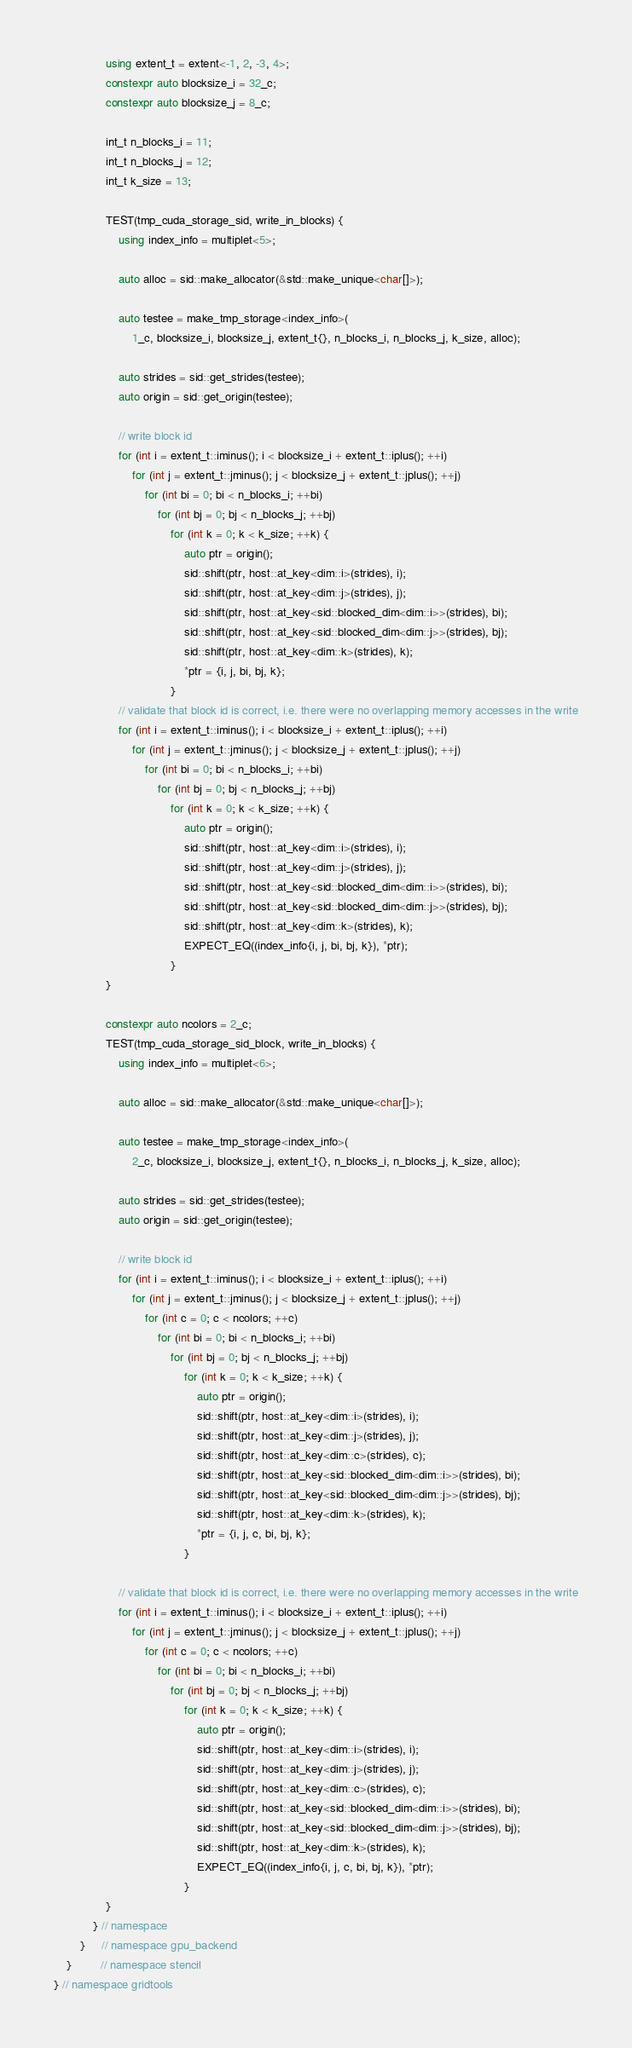Convert code to text. <code><loc_0><loc_0><loc_500><loc_500><_C++_>                using extent_t = extent<-1, 2, -3, 4>;
                constexpr auto blocksize_i = 32_c;
                constexpr auto blocksize_j = 8_c;

                int_t n_blocks_i = 11;
                int_t n_blocks_j = 12;
                int_t k_size = 13;

                TEST(tmp_cuda_storage_sid, write_in_blocks) {
                    using index_info = multiplet<5>;

                    auto alloc = sid::make_allocator(&std::make_unique<char[]>);

                    auto testee = make_tmp_storage<index_info>(
                        1_c, blocksize_i, blocksize_j, extent_t{}, n_blocks_i, n_blocks_j, k_size, alloc);

                    auto strides = sid::get_strides(testee);
                    auto origin = sid::get_origin(testee);

                    // write block id
                    for (int i = extent_t::iminus(); i < blocksize_i + extent_t::iplus(); ++i)
                        for (int j = extent_t::jminus(); j < blocksize_j + extent_t::jplus(); ++j)
                            for (int bi = 0; bi < n_blocks_i; ++bi)
                                for (int bj = 0; bj < n_blocks_j; ++bj)
                                    for (int k = 0; k < k_size; ++k) {
                                        auto ptr = origin();
                                        sid::shift(ptr, host::at_key<dim::i>(strides), i);
                                        sid::shift(ptr, host::at_key<dim::j>(strides), j);
                                        sid::shift(ptr, host::at_key<sid::blocked_dim<dim::i>>(strides), bi);
                                        sid::shift(ptr, host::at_key<sid::blocked_dim<dim::j>>(strides), bj);
                                        sid::shift(ptr, host::at_key<dim::k>(strides), k);
                                        *ptr = {i, j, bi, bj, k};
                                    }
                    // validate that block id is correct, i.e. there were no overlapping memory accesses in the write
                    for (int i = extent_t::iminus(); i < blocksize_i + extent_t::iplus(); ++i)
                        for (int j = extent_t::jminus(); j < blocksize_j + extent_t::jplus(); ++j)
                            for (int bi = 0; bi < n_blocks_i; ++bi)
                                for (int bj = 0; bj < n_blocks_j; ++bj)
                                    for (int k = 0; k < k_size; ++k) {
                                        auto ptr = origin();
                                        sid::shift(ptr, host::at_key<dim::i>(strides), i);
                                        sid::shift(ptr, host::at_key<dim::j>(strides), j);
                                        sid::shift(ptr, host::at_key<sid::blocked_dim<dim::i>>(strides), bi);
                                        sid::shift(ptr, host::at_key<sid::blocked_dim<dim::j>>(strides), bj);
                                        sid::shift(ptr, host::at_key<dim::k>(strides), k);
                                        EXPECT_EQ((index_info{i, j, bi, bj, k}), *ptr);
                                    }
                }

                constexpr auto ncolors = 2_c;
                TEST(tmp_cuda_storage_sid_block, write_in_blocks) {
                    using index_info = multiplet<6>;

                    auto alloc = sid::make_allocator(&std::make_unique<char[]>);

                    auto testee = make_tmp_storage<index_info>(
                        2_c, blocksize_i, blocksize_j, extent_t{}, n_blocks_i, n_blocks_j, k_size, alloc);

                    auto strides = sid::get_strides(testee);
                    auto origin = sid::get_origin(testee);

                    // write block id
                    for (int i = extent_t::iminus(); i < blocksize_i + extent_t::iplus(); ++i)
                        for (int j = extent_t::jminus(); j < blocksize_j + extent_t::jplus(); ++j)
                            for (int c = 0; c < ncolors; ++c)
                                for (int bi = 0; bi < n_blocks_i; ++bi)
                                    for (int bj = 0; bj < n_blocks_j; ++bj)
                                        for (int k = 0; k < k_size; ++k) {
                                            auto ptr = origin();
                                            sid::shift(ptr, host::at_key<dim::i>(strides), i);
                                            sid::shift(ptr, host::at_key<dim::j>(strides), j);
                                            sid::shift(ptr, host::at_key<dim::c>(strides), c);
                                            sid::shift(ptr, host::at_key<sid::blocked_dim<dim::i>>(strides), bi);
                                            sid::shift(ptr, host::at_key<sid::blocked_dim<dim::j>>(strides), bj);
                                            sid::shift(ptr, host::at_key<dim::k>(strides), k);
                                            *ptr = {i, j, c, bi, bj, k};
                                        }

                    // validate that block id is correct, i.e. there were no overlapping memory accesses in the write
                    for (int i = extent_t::iminus(); i < blocksize_i + extent_t::iplus(); ++i)
                        for (int j = extent_t::jminus(); j < blocksize_j + extent_t::jplus(); ++j)
                            for (int c = 0; c < ncolors; ++c)
                                for (int bi = 0; bi < n_blocks_i; ++bi)
                                    for (int bj = 0; bj < n_blocks_j; ++bj)
                                        for (int k = 0; k < k_size; ++k) {
                                            auto ptr = origin();
                                            sid::shift(ptr, host::at_key<dim::i>(strides), i);
                                            sid::shift(ptr, host::at_key<dim::j>(strides), j);
                                            sid::shift(ptr, host::at_key<dim::c>(strides), c);
                                            sid::shift(ptr, host::at_key<sid::blocked_dim<dim::i>>(strides), bi);
                                            sid::shift(ptr, host::at_key<sid::blocked_dim<dim::j>>(strides), bj);
                                            sid::shift(ptr, host::at_key<dim::k>(strides), k);
                                            EXPECT_EQ((index_info{i, j, c, bi, bj, k}), *ptr);
                                        }
                }
            } // namespace
        }     // namespace gpu_backend
    }         // namespace stencil
} // namespace gridtools
</code> 